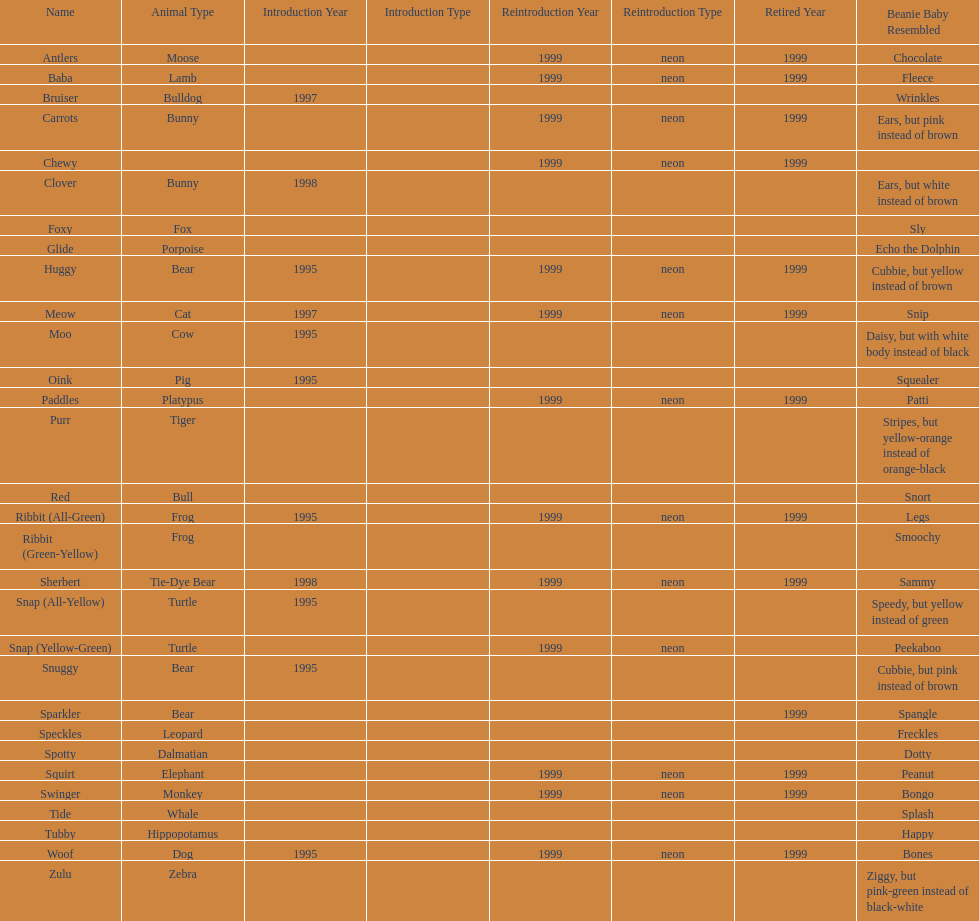How many total pillow pals were both reintroduced and retired in 1999? 12. 